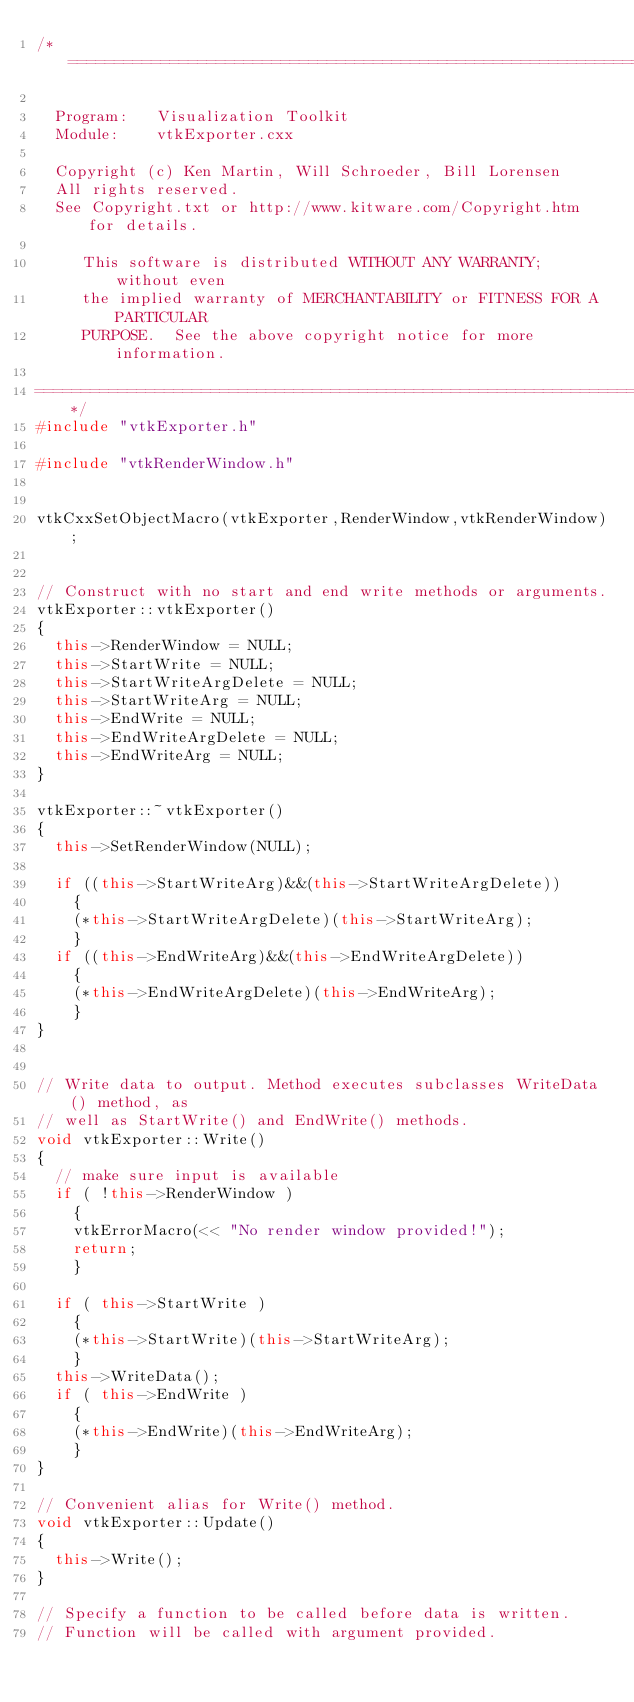Convert code to text. <code><loc_0><loc_0><loc_500><loc_500><_C++_>/*=========================================================================

  Program:   Visualization Toolkit
  Module:    vtkExporter.cxx

  Copyright (c) Ken Martin, Will Schroeder, Bill Lorensen
  All rights reserved.
  See Copyright.txt or http://www.kitware.com/Copyright.htm for details.

     This software is distributed WITHOUT ANY WARRANTY; without even
     the implied warranty of MERCHANTABILITY or FITNESS FOR A PARTICULAR
     PURPOSE.  See the above copyright notice for more information.

=========================================================================*/
#include "vtkExporter.h"

#include "vtkRenderWindow.h"


vtkCxxSetObjectMacro(vtkExporter,RenderWindow,vtkRenderWindow);


// Construct with no start and end write methods or arguments.
vtkExporter::vtkExporter()
{
  this->RenderWindow = NULL;
  this->StartWrite = NULL;
  this->StartWriteArgDelete = NULL;
  this->StartWriteArg = NULL;
  this->EndWrite = NULL;
  this->EndWriteArgDelete = NULL;
  this->EndWriteArg = NULL;
}

vtkExporter::~vtkExporter()
{
  this->SetRenderWindow(NULL);

  if ((this->StartWriteArg)&&(this->StartWriteArgDelete))
    {
    (*this->StartWriteArgDelete)(this->StartWriteArg);
    }
  if ((this->EndWriteArg)&&(this->EndWriteArgDelete))
    {
    (*this->EndWriteArgDelete)(this->EndWriteArg);
    }
}


// Write data to output. Method executes subclasses WriteData() method, as
// well as StartWrite() and EndWrite() methods.
void vtkExporter::Write()
{
  // make sure input is available
  if ( !this->RenderWindow )
    {
    vtkErrorMacro(<< "No render window provided!");
    return;
    }

  if ( this->StartWrite )
    {
    (*this->StartWrite)(this->StartWriteArg);
    }
  this->WriteData();
  if ( this->EndWrite )
    {
    (*this->EndWrite)(this->EndWriteArg);
    }
}

// Convenient alias for Write() method.
void vtkExporter::Update()
{
  this->Write();
}

// Specify a function to be called before data is written.
// Function will be called with argument provided.</code> 